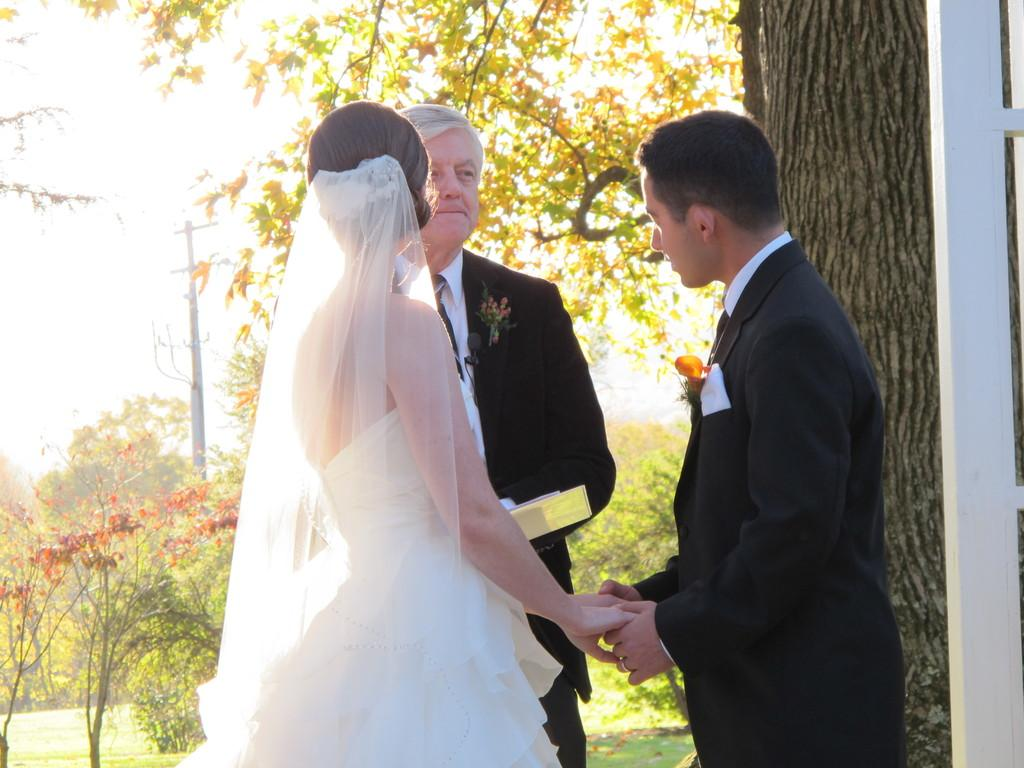How many people are standing in the image? There are two men and a woman standing in the image. Are the man and woman interacting in any way? Yes, the man and woman are holding hands. What type of natural elements can be seen in the image? There are trees in the image. What other objects or structures can be seen in the image? There appears to be a pole and a tree trunk visible in the image. Where is the bone located in the image? There is no bone present in the image. Can you describe the alley in the image? There is no alley present in the image. 